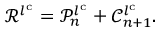<formula> <loc_0><loc_0><loc_500><loc_500>\ m a t h s c r { R } ^ { l ^ { c } } = \ m a t h s c r { P } _ { n } ^ { l ^ { c } } + \ m a t h s c r { C } _ { n + 1 } ^ { l ^ { c } } .</formula> 